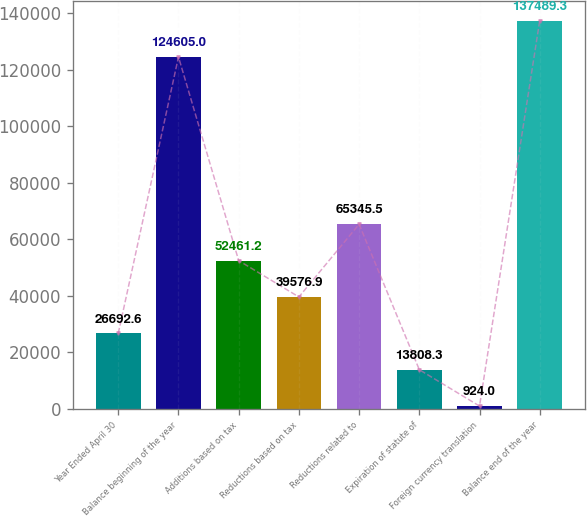<chart> <loc_0><loc_0><loc_500><loc_500><bar_chart><fcel>Year Ended April 30<fcel>Balance beginning of the year<fcel>Additions based on tax<fcel>Reductions based on tax<fcel>Reductions related to<fcel>Expiration of statute of<fcel>Foreign currency translation<fcel>Balance end of the year<nl><fcel>26692.6<fcel>124605<fcel>52461.2<fcel>39576.9<fcel>65345.5<fcel>13808.3<fcel>924<fcel>137489<nl></chart> 